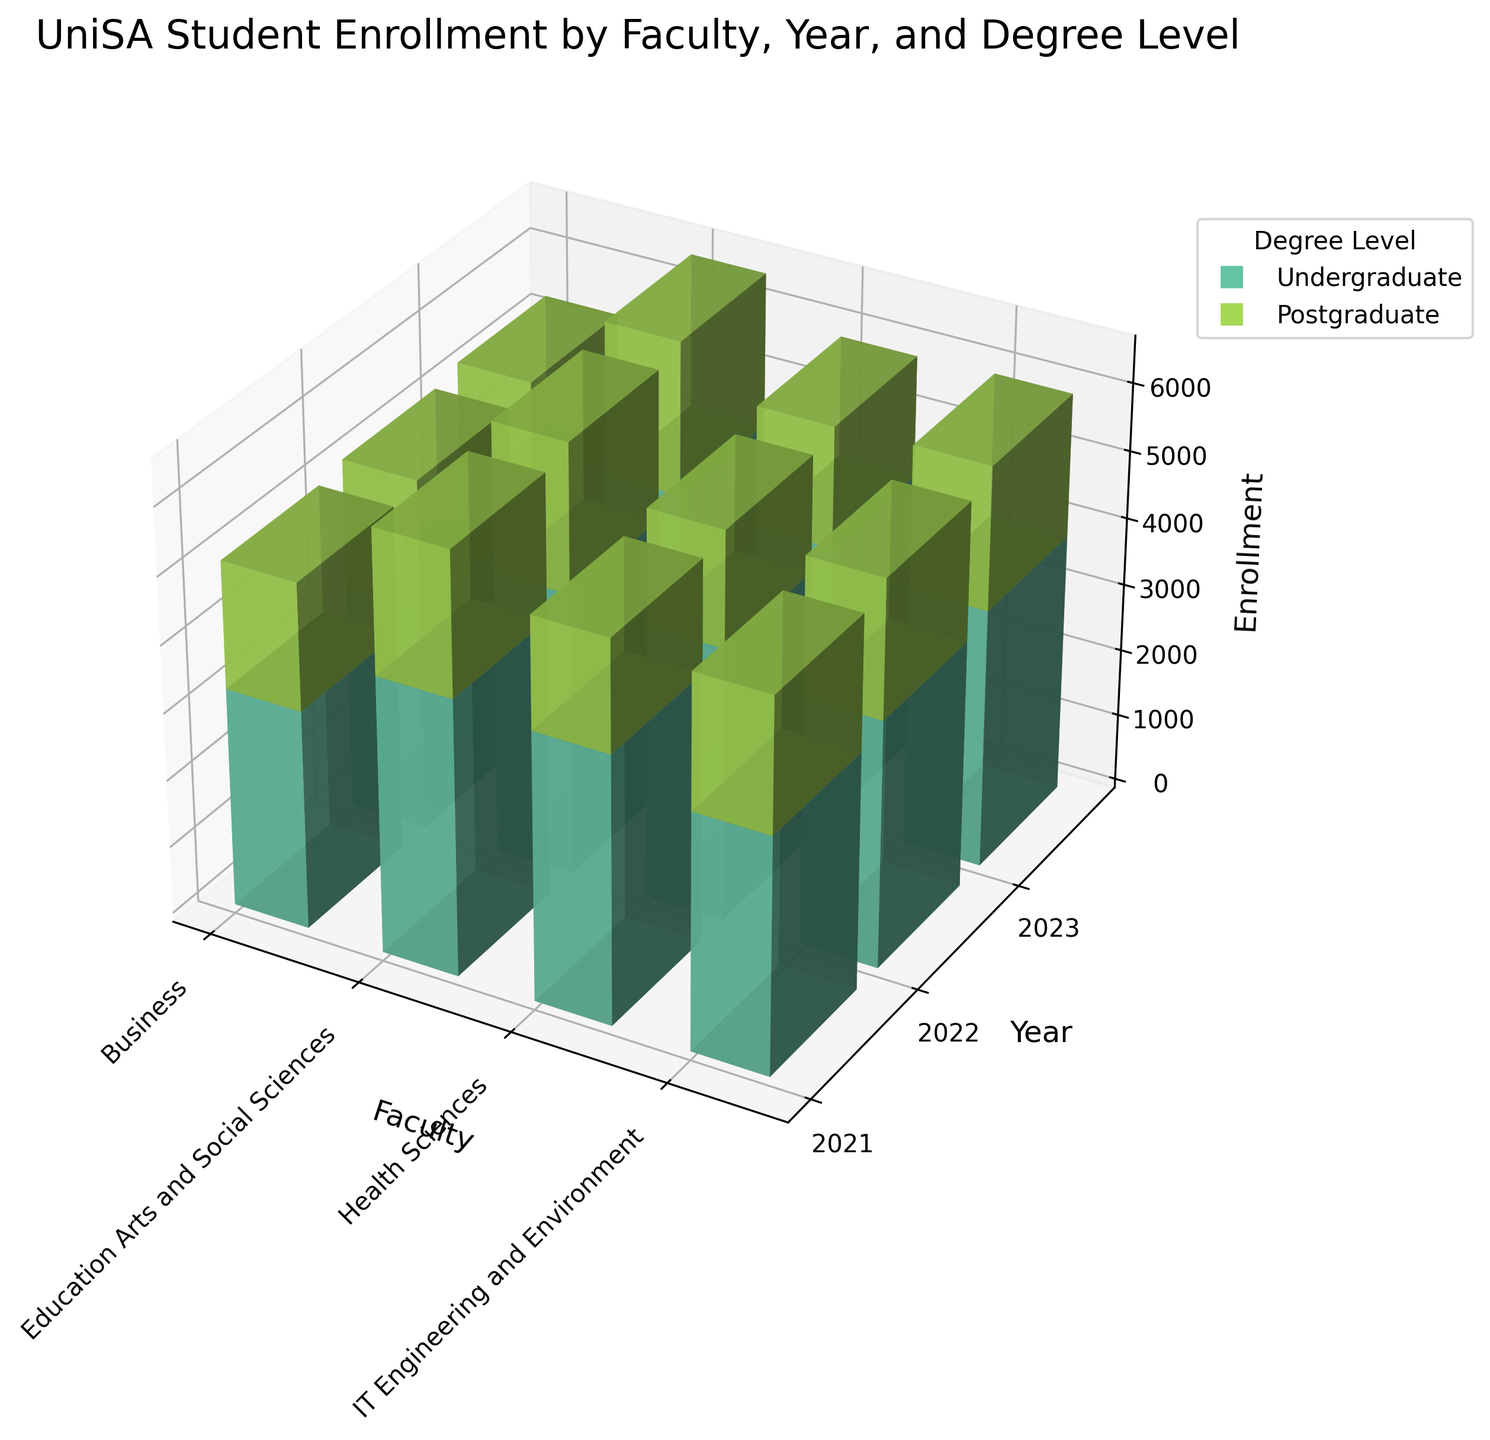What's the title of the figure? The title is usually displayed at the top of the figure. In this case, the title is "UniSA Student Enrollment by Faculty, Year, and Degree Level," as mentioned in the code.
Answer: UniSA Student Enrollment by Faculty, Year, and Degree Level How many faculties are represented in the figure? By analyzing the x-axis labels, which represent different faculties, we find there are four faculties represented.
Answer: Four In which year did the Faculty of Business have the highest undergraduate enrollment? Compare the heights of the bars corresponding to the Faculty of Business across the years 2021, 2022, and 2023, and observe that 2023 has the highest bar for undergraduate enrollment.
Answer: 2023 What is the trend in postgraduate enrollment in Education Arts and Social Sciences from 2021 to 2023? Observe the bars for postgraduate enrollments in Education Arts and Social Sciences for the years 2021, 2022, and 2023. The heights increase from 2133 (2021) to 2201 (2022) to 2267 (2023), showing a consistent upward trend.
Answer: Increasing Compare the total enrollments in Health Sciences in 2021 and 2023. Which year had higher total enrollments? Add the undergraduate and postgraduate enrollments for Health Sciences in 2021 (3987 + 1654) and 2023 (4134 + 1778). The calculations are 5641 (2021) and 5912 (2023), respectively, indicating higher total enrollments in 2023.
Answer: 2023 Which degree level in IT Engineering and Environment had an increase in enrollment every year from 2021 to 2023? Examine the height of the undergraduate and postgraduate bars in the IT Engineering and Environment faculty from 2021 through 2023. The undergraduate enrollment bars increase each year (3521 in 2021, 3678 in 2022, and 3842 in 2023).
Answer: Undergraduate What was the total number of enrollments for all faculties in 2022? Sum up the enrollments for each faculty across both undergraduate and postgraduate levels in 2022. Business (3312 + 1923), Education Arts and Social Sciences (4198 + 2201), Health Sciences (4056 + 1712), IT Engineering and Environment (3678 + 2045). The total is 5235 (Business) + 6399 (Education Arts and Social Sciences) + 5768 (Health Sciences) + 5723 (IT Engineering and Environment), which equals 23125.
Answer: 23125 Between which two faculties is the postgraduate enrollment for 2023 closest in value? Compare the heights of the postgraduate enrollment bars for each faculty in 2023: Business (1976), Education Arts and Social Sciences (2267), Health Sciences (1778), IT Engineering and Environment (2112). The closest values are from Business (1976) and IT Engineering and Environment (2112), with a difference of 136.
Answer: Business and IT Engineering and Environment Which faculty saw a decrease in undergraduate enrollment from 2022 to 2023? Compare the heights of the undergraduate bars for all faculties from 2022 to 2023. IT Engineering and Environment's enrollment decreased from 3678 in 2022 to 3842 in 2023.
Answer: None Which faculty had the most consistent undergraduate enrollment over the three years? Identify the faculty whose undergraduate enrollment bars are closest in height from 2021 to 2023. For instance, the Business faculty’s undergraduate enrollments are 3245 (2021), 3312 (2022), and 3389 (2023), showing slight increases each year.
Answer: Business 